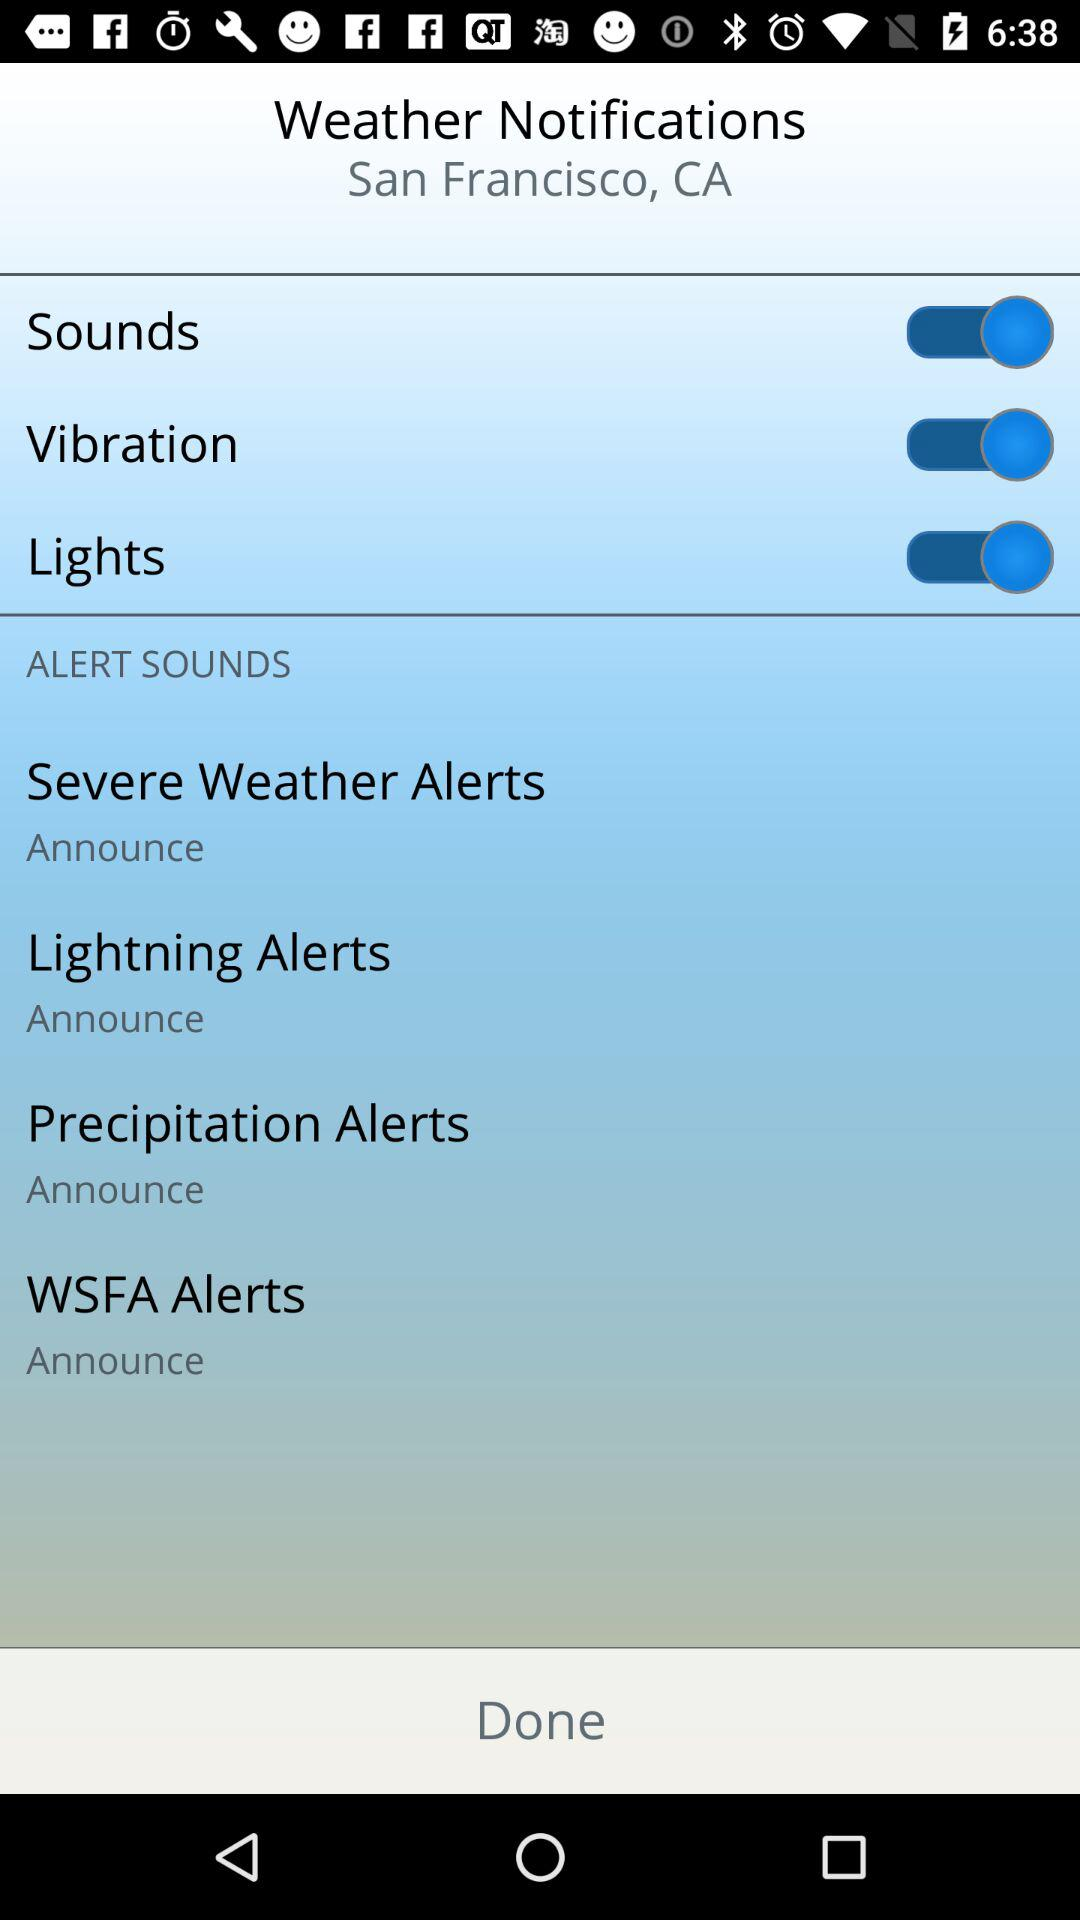What is the location? The location is San Francisco, CA. 